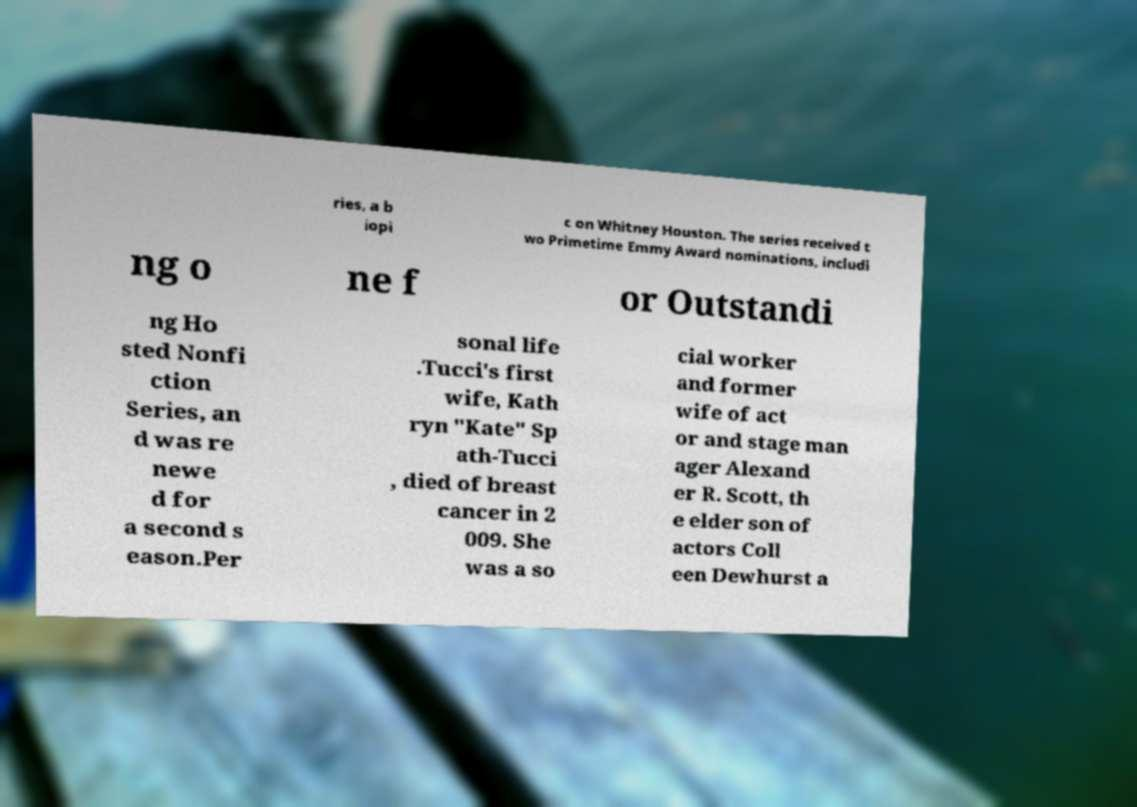What messages or text are displayed in this image? I need them in a readable, typed format. ries, a b iopi c on Whitney Houston. The series received t wo Primetime Emmy Award nominations, includi ng o ne f or Outstandi ng Ho sted Nonfi ction Series, an d was re newe d for a second s eason.Per sonal life .Tucci's first wife, Kath ryn "Kate" Sp ath-Tucci , died of breast cancer in 2 009. She was a so cial worker and former wife of act or and stage man ager Alexand er R. Scott, th e elder son of actors Coll een Dewhurst a 